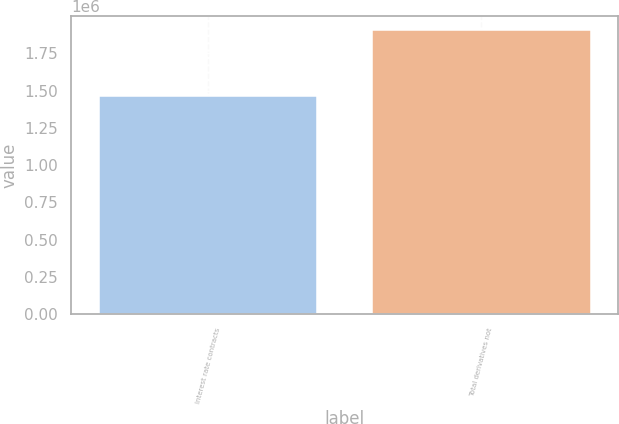Convert chart to OTSL. <chart><loc_0><loc_0><loc_500><loc_500><bar_chart><fcel>Interest rate contracts<fcel>Total derivatives not<nl><fcel>1.46706e+06<fcel>1.90432e+06<nl></chart> 